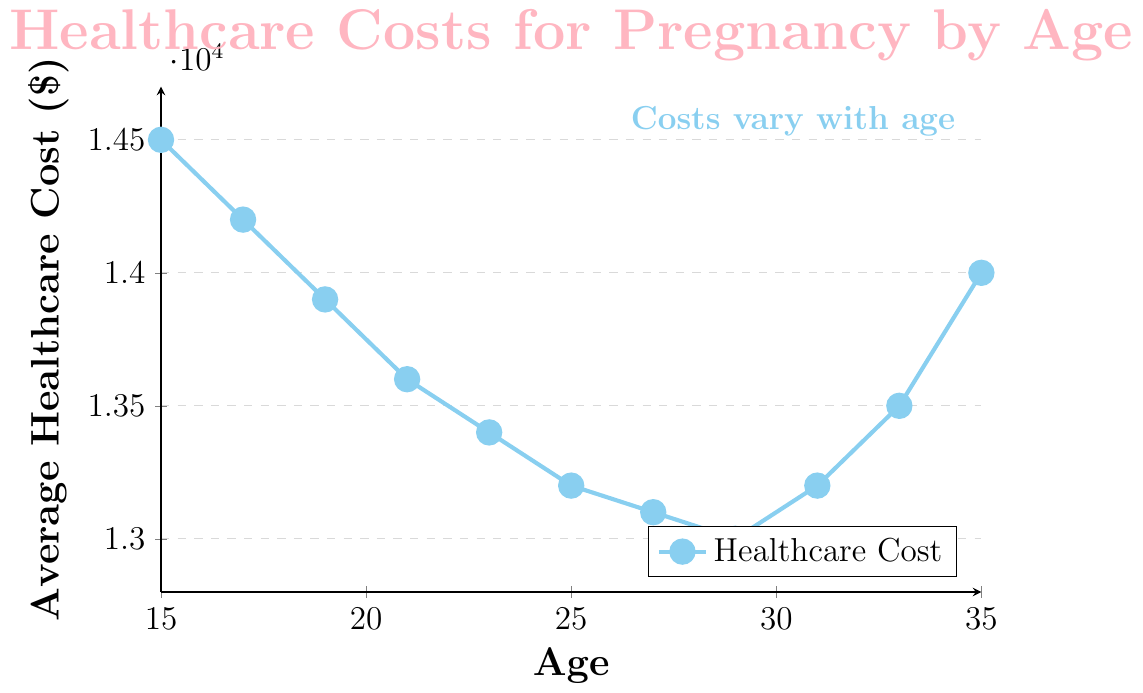What age group has the lowest average healthcare cost? The line chart shows healthcare costs decreasing to their lowest point and then rising again. The lowest point is at age 29.
Answer: 29 What is the difference in the average healthcare cost between ages 15 and 35? The healthcare cost at age 15 is $14,500, and at age 35 it is $14,000. The difference is calculated as $14,500 - $14,000.
Answer: $500 How does the average healthcare cost change between ages 21 and 23? Look at the plotted points for age 21 and age 23. At age 21, it is $13,600, and at age 23, it is $13,400. The change is calculated as $13,400 - $13,600.
Answer: -$200 Which age group experiences an increase in average healthcare costs compared to the previous age group? Observing the plotted points, ages 31 to 33 show an increase from $13,200 to $13,500, and ages 33 to 35 show an increase from $13,500 to $14,000.
Answer: 31-33, 33-35 What is the average healthcare cost between the ages of 25 and 29? The average healthcare costs for ages 25, 27, and 29 are $13,200, $13,100, and $13,000, respectively. Average = ($13,200 + $13,100 + $13,000) / 3.
Answer: $13,100 How does the healthcare cost trend visually change between ages 15 and 21? The line descends from $14,500 at age 15 to $13,600 at age 21, indicating a steady decline.
Answer: Steady decline Between which ages does the average healthcare cost remain largely unchanged? Observing the line chart, between ages 27 ($13,100) and 29 ($13,000), the costs remain nearly the same.
Answer: 27-29 What is the average healthcare cost at age 21 compared to age 31? The cost at age 21 is $13,600 and at age 31 is $13,200.
Answer: $13,600 vs $13,200 By how much does the average healthcare cost decrease from age 17 to age 27? The cost at age 17 is $14,200, and at age 27, it is $13,100. The decrease is $14,200 - $13,100.
Answer: $1,100 